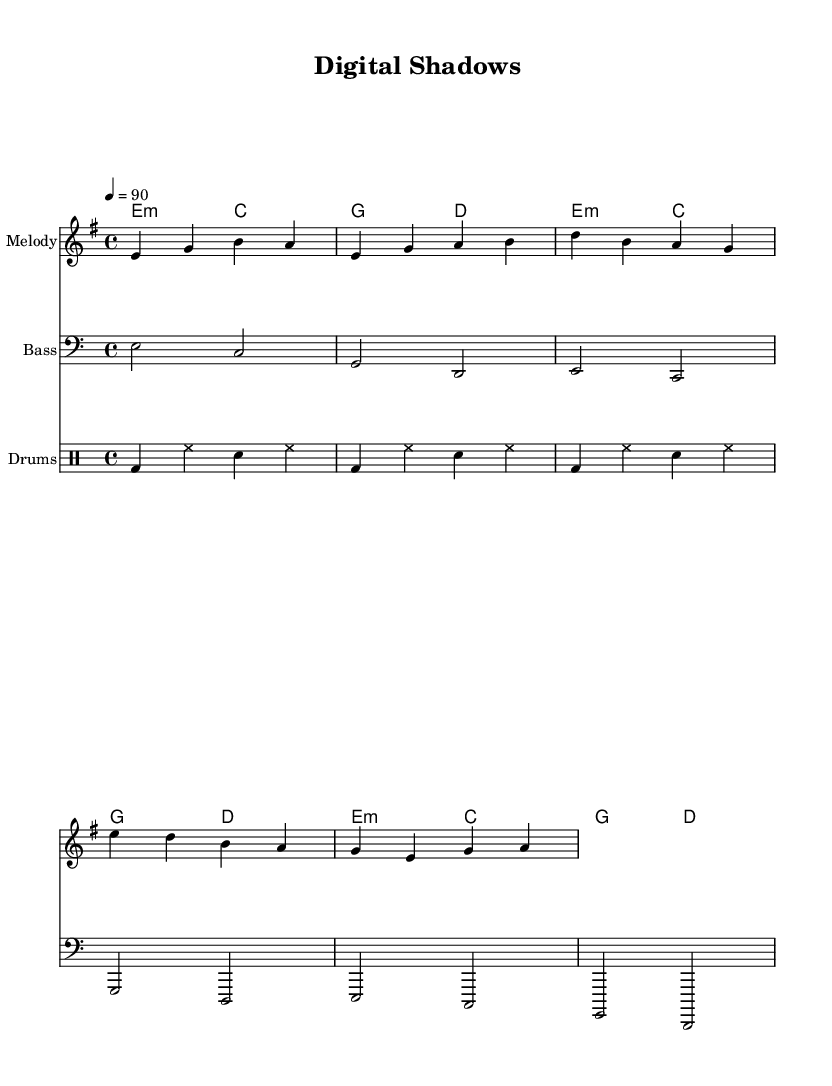What is the key signature of this music? The key signature is indicated at the beginning of the staff with one flat, which corresponds to E minor.
Answer: E minor What is the time signature of this music? The time signature is represented as "4/4" at the beginning of the sheet music, meaning four beats per measure.
Answer: 4/4 What is the tempo marking in the music? The tempo is specified in beats per minute, indicated as "4 = 90," meaning 90 beats per minute.
Answer: 90 How many measures are there in the melody? By counting the measures in the melody section, there are a total of 6 measures indicated.
Answer: 6 What style is this music composition identified with? The title "Digital Shadows" suggests that this composition is reflected in the conscious hip hop style, which often addresses social issues.
Answer: Conscious hip hop How many different parts are presented in this score? The score contains four parts: Chord Names, Melody, Bass, and Drums, as can be seen in the score layout section.
Answer: Four 